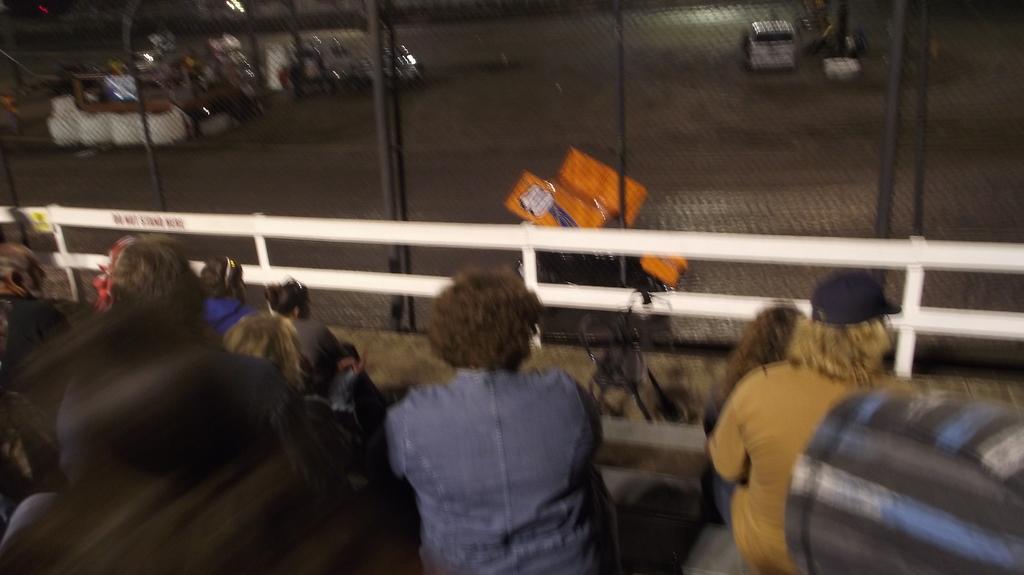Could you give a brief overview of what you see in this image? In this picture we can see a group of people sitting, chair, fences and in the background we can see vehicles on the road. 